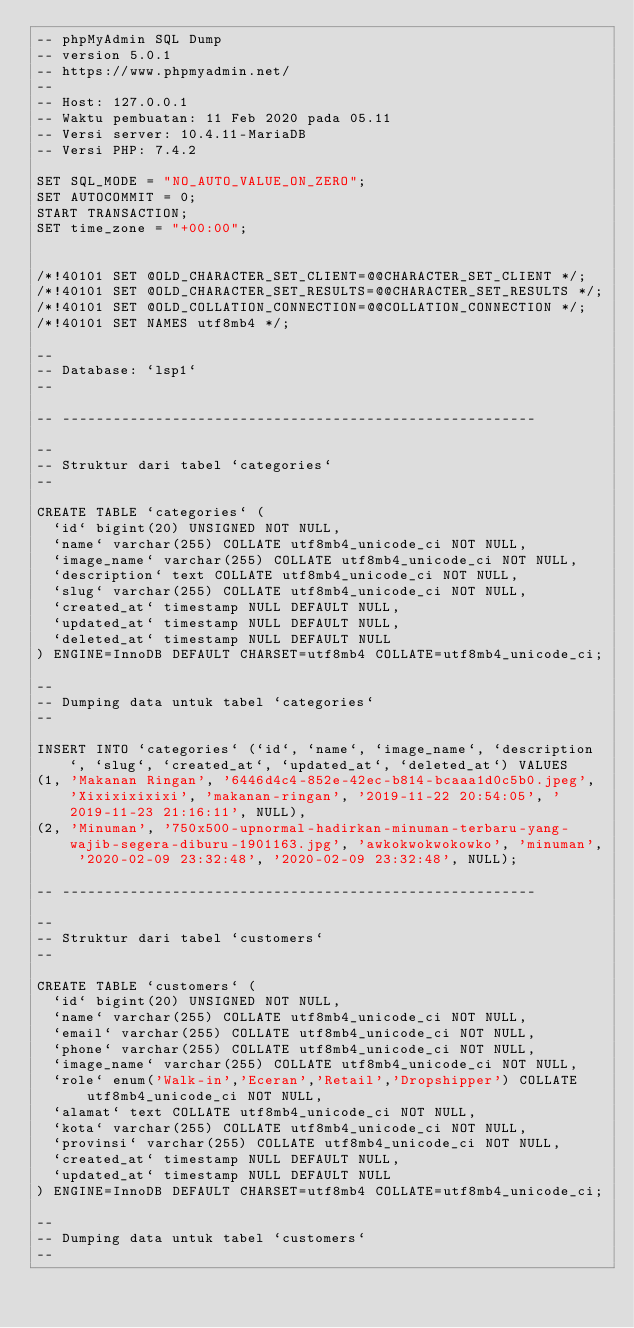Convert code to text. <code><loc_0><loc_0><loc_500><loc_500><_SQL_>-- phpMyAdmin SQL Dump
-- version 5.0.1
-- https://www.phpmyadmin.net/
--
-- Host: 127.0.0.1
-- Waktu pembuatan: 11 Feb 2020 pada 05.11
-- Versi server: 10.4.11-MariaDB
-- Versi PHP: 7.4.2

SET SQL_MODE = "NO_AUTO_VALUE_ON_ZERO";
SET AUTOCOMMIT = 0;
START TRANSACTION;
SET time_zone = "+00:00";


/*!40101 SET @OLD_CHARACTER_SET_CLIENT=@@CHARACTER_SET_CLIENT */;
/*!40101 SET @OLD_CHARACTER_SET_RESULTS=@@CHARACTER_SET_RESULTS */;
/*!40101 SET @OLD_COLLATION_CONNECTION=@@COLLATION_CONNECTION */;
/*!40101 SET NAMES utf8mb4 */;

--
-- Database: `lsp1`
--

-- --------------------------------------------------------

--
-- Struktur dari tabel `categories`
--

CREATE TABLE `categories` (
  `id` bigint(20) UNSIGNED NOT NULL,
  `name` varchar(255) COLLATE utf8mb4_unicode_ci NOT NULL,
  `image_name` varchar(255) COLLATE utf8mb4_unicode_ci NOT NULL,
  `description` text COLLATE utf8mb4_unicode_ci NOT NULL,
  `slug` varchar(255) COLLATE utf8mb4_unicode_ci NOT NULL,
  `created_at` timestamp NULL DEFAULT NULL,
  `updated_at` timestamp NULL DEFAULT NULL,
  `deleted_at` timestamp NULL DEFAULT NULL
) ENGINE=InnoDB DEFAULT CHARSET=utf8mb4 COLLATE=utf8mb4_unicode_ci;

--
-- Dumping data untuk tabel `categories`
--

INSERT INTO `categories` (`id`, `name`, `image_name`, `description`, `slug`, `created_at`, `updated_at`, `deleted_at`) VALUES
(1, 'Makanan Ringan', '6446d4c4-852e-42ec-b814-bcaaa1d0c5b0.jpeg', 'Xixixixixixi', 'makanan-ringan', '2019-11-22 20:54:05', '2019-11-23 21:16:11', NULL),
(2, 'Minuman', '750x500-upnormal-hadirkan-minuman-terbaru-yang-wajib-segera-diburu-1901163.jpg', 'awkokwokwokowko', 'minuman', '2020-02-09 23:32:48', '2020-02-09 23:32:48', NULL);

-- --------------------------------------------------------

--
-- Struktur dari tabel `customers`
--

CREATE TABLE `customers` (
  `id` bigint(20) UNSIGNED NOT NULL,
  `name` varchar(255) COLLATE utf8mb4_unicode_ci NOT NULL,
  `email` varchar(255) COLLATE utf8mb4_unicode_ci NOT NULL,
  `phone` varchar(255) COLLATE utf8mb4_unicode_ci NOT NULL,
  `image_name` varchar(255) COLLATE utf8mb4_unicode_ci NOT NULL,
  `role` enum('Walk-in','Eceran','Retail','Dropshipper') COLLATE utf8mb4_unicode_ci NOT NULL,
  `alamat` text COLLATE utf8mb4_unicode_ci NOT NULL,
  `kota` varchar(255) COLLATE utf8mb4_unicode_ci NOT NULL,
  `provinsi` varchar(255) COLLATE utf8mb4_unicode_ci NOT NULL,
  `created_at` timestamp NULL DEFAULT NULL,
  `updated_at` timestamp NULL DEFAULT NULL
) ENGINE=InnoDB DEFAULT CHARSET=utf8mb4 COLLATE=utf8mb4_unicode_ci;

--
-- Dumping data untuk tabel `customers`
--
</code> 